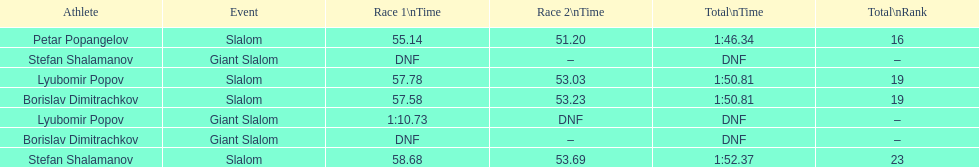How many athletes are there total? 4. Could you parse the entire table? {'header': ['Athlete', 'Event', 'Race 1\\nTime', 'Race 2\\nTime', 'Total\\nTime', 'Total\\nRank'], 'rows': [['Petar Popangelov', 'Slalom', '55.14', '51.20', '1:46.34', '16'], ['Stefan Shalamanov', 'Giant Slalom', 'DNF', '–', 'DNF', '–'], ['Lyubomir Popov', 'Slalom', '57.78', '53.03', '1:50.81', '19'], ['Borislav Dimitrachkov', 'Slalom', '57.58', '53.23', '1:50.81', '19'], ['Lyubomir Popov', 'Giant Slalom', '1:10.73', 'DNF', 'DNF', '–'], ['Borislav Dimitrachkov', 'Giant Slalom', 'DNF', '–', 'DNF', '–'], ['Stefan Shalamanov', 'Slalom', '58.68', '53.69', '1:52.37', '23']]} 